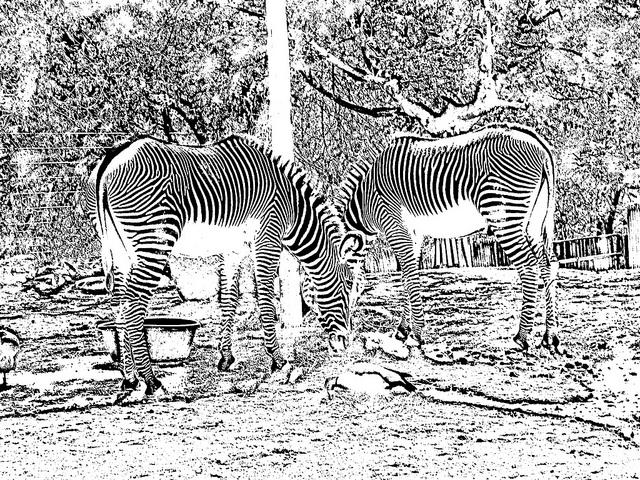How was the photo turned black and white? Please explain your reasoning. filter. A filter is used to digitally turn photos black and white. 